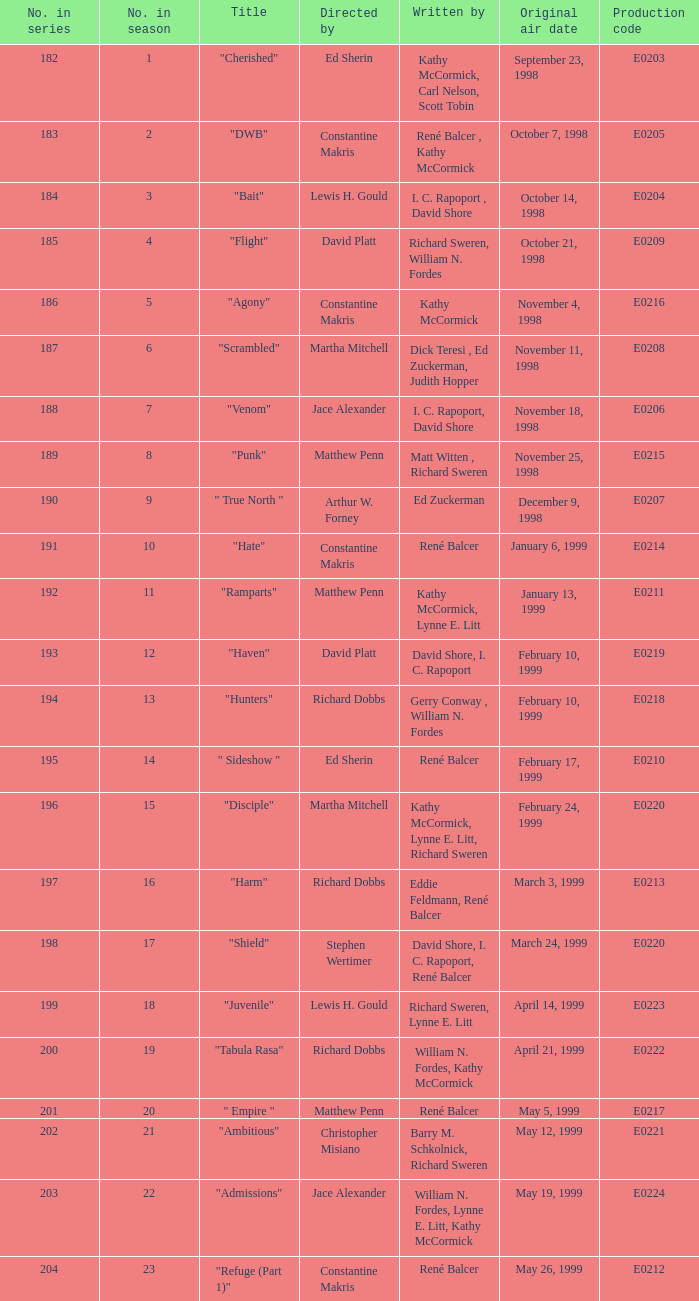The episode that premiered on january 13, 1999 was penned by whom? Kathy McCormick, Lynne E. Litt. 